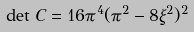<formula> <loc_0><loc_0><loc_500><loc_500>\det \, C = 1 6 \pi ^ { 4 } ( \pi ^ { 2 } - 8 \xi ^ { 2 } ) ^ { 2 }</formula> 